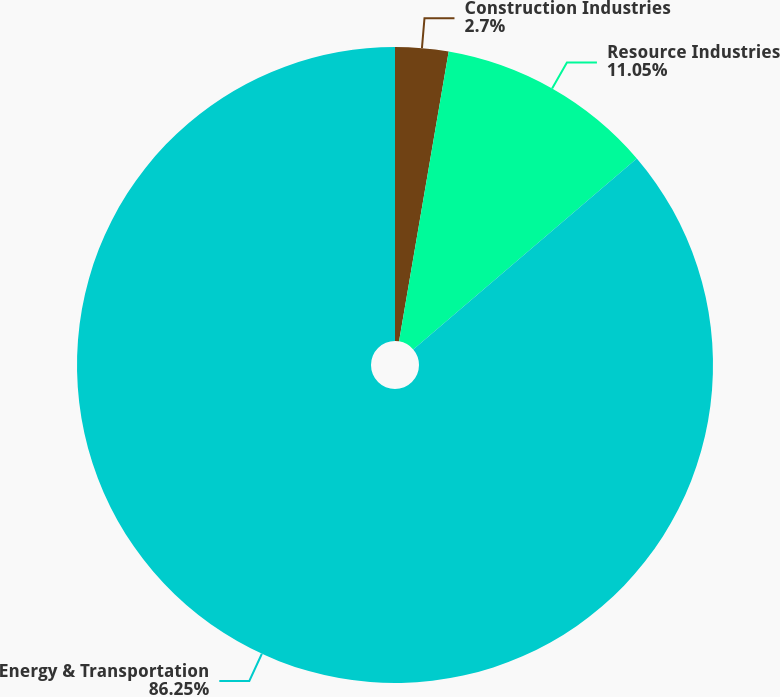Convert chart to OTSL. <chart><loc_0><loc_0><loc_500><loc_500><pie_chart><fcel>Construction Industries<fcel>Resource Industries<fcel>Energy & Transportation<nl><fcel>2.7%<fcel>11.05%<fcel>86.25%<nl></chart> 